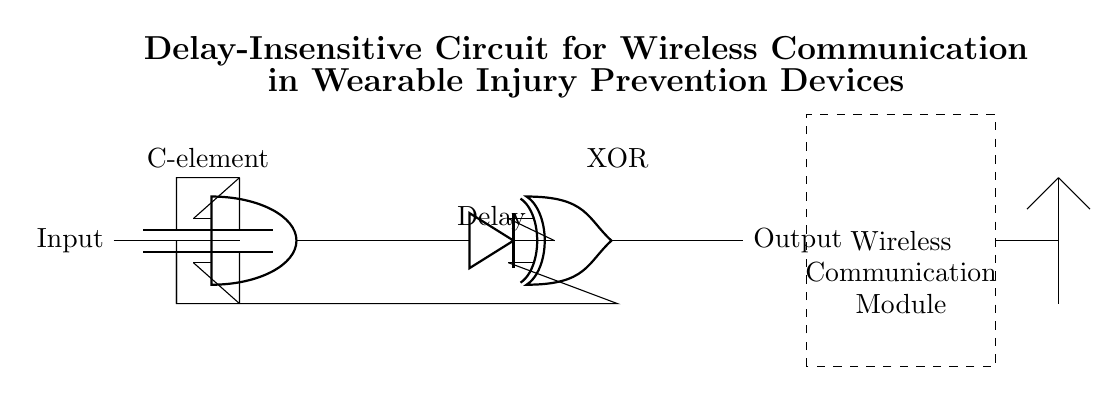What is the type of the main gate used in the circuit? The main gate used in the circuit is a C-element, which can be identified from the labeled node in the diagram as well as its connections to input and outputs.
Answer: C-element What is the purpose of the delay element in the circuit? The delay element is used to synchronize signals before they reach the XOR gate, allowing for proper timing and coordination of data transmission.
Answer: Synchronization How many components are used to implement the XOR function? The XOR function in this circuit utilizes a single XOR gate to perform the function, as indicated by the node labeled as XOR in the diagram.
Answer: One What does the dashed rectangle represent in the circuit? The dashed rectangle represents the wireless communication module, as noted by the labeling within the rectangle and its placement in the circuit.
Answer: Wireless communication module What is the output of the XOR gate connected to in the circuit? The output of the XOR gate is directly connected to the output node of the circuit, as shown by the line extending from the XOR gate to the right side of the diagram.
Answer: Output Why is the C-element crucial in a delay-insensitive circuit? The C-element is crucial as it allows the circuit to operate without being affected by variations in signal delays, enabling reliable communication essential for injury prevention devices.
Answer: Reliable communication 